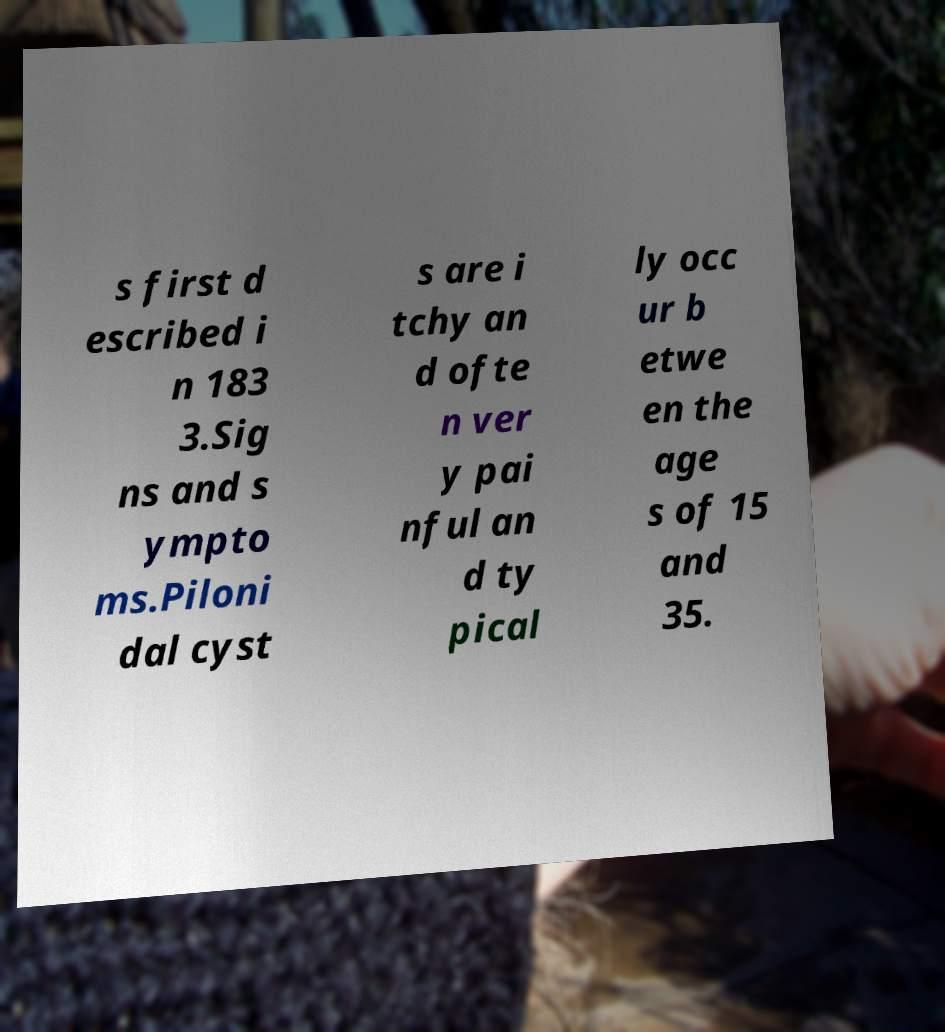Could you assist in decoding the text presented in this image and type it out clearly? s first d escribed i n 183 3.Sig ns and s ympto ms.Piloni dal cyst s are i tchy an d ofte n ver y pai nful an d ty pical ly occ ur b etwe en the age s of 15 and 35. 